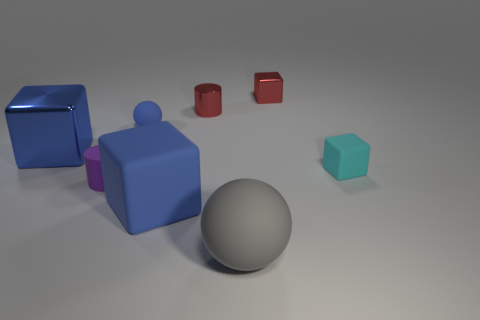Subtract all large metallic blocks. How many blocks are left? 3 Subtract all green cylinders. How many blue cubes are left? 2 Add 2 big metal spheres. How many objects exist? 10 Subtract all red cylinders. How many cylinders are left? 1 Subtract all cylinders. How many objects are left? 6 Subtract all gray spheres. Subtract all blue cylinders. How many spheres are left? 1 Subtract all red cubes. Subtract all tiny cyan rubber blocks. How many objects are left? 6 Add 2 red cylinders. How many red cylinders are left? 3 Add 7 large cubes. How many large cubes exist? 9 Subtract 1 cyan cubes. How many objects are left? 7 